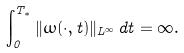Convert formula to latex. <formula><loc_0><loc_0><loc_500><loc_500>\int _ { 0 } ^ { T _ { * } } \| \omega ( \cdot , t ) \| _ { L ^ { \infty } } \, d t = \infty .</formula> 